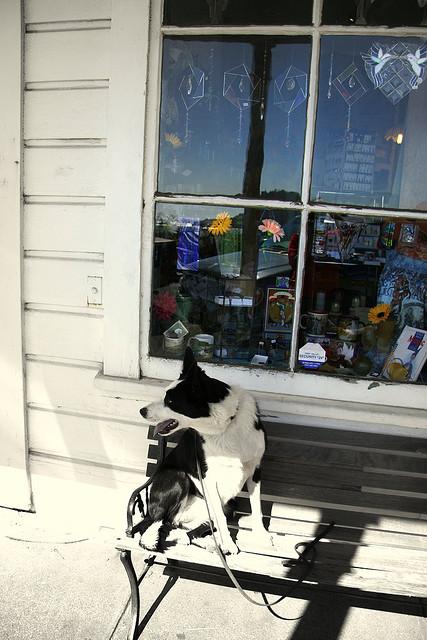What is covering the window?
Be succinct. Glass. Why is the dog tied to a bench?
Give a very brief answer. Yes. What is on the bench?
Keep it brief. Dog. Is this dog's head in the shade?
Short answer required. Yes. Is this dog waiting for someone?
Concise answer only. Yes. 